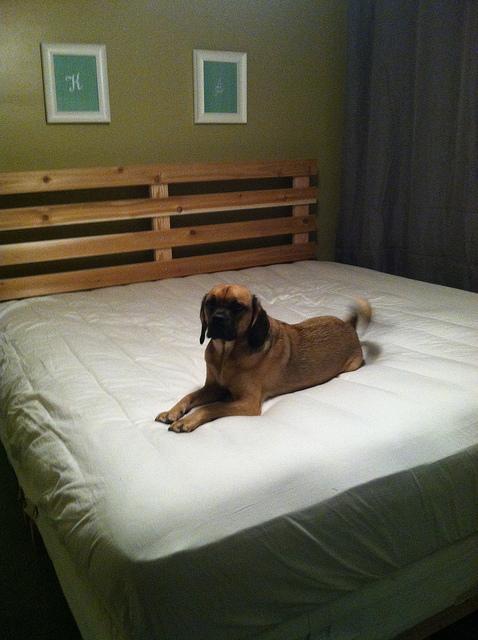Which room is this?
Answer briefly. Bedroom. What is the animal?
Keep it brief. Dog. What letter is displayed in the picture on the left?
Concise answer only. K. 